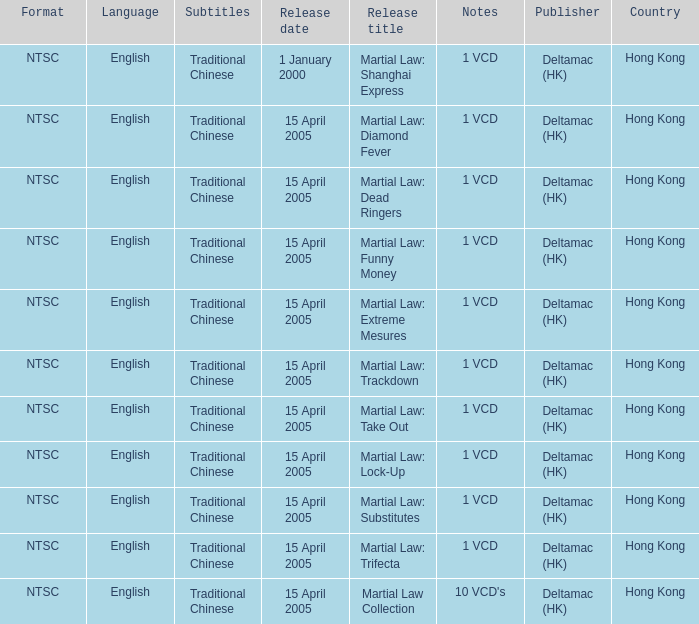Who was the publisher of Martial Law: Dead Ringers? Deltamac (HK). 